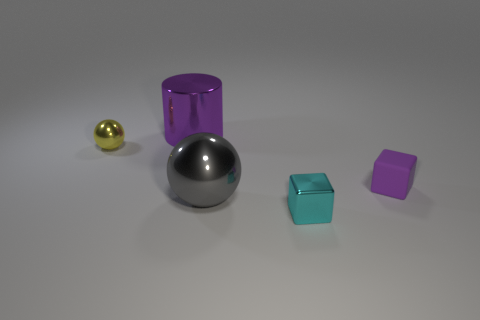What size is the metallic sphere to the left of the metallic cylinder?
Your answer should be compact. Small. How many other objects are there of the same color as the shiny block?
Your answer should be very brief. 0. There is a purple object that is on the right side of the object that is behind the small yellow metal object; what is it made of?
Your answer should be compact. Rubber. Does the tiny rubber thing that is to the right of the big purple metallic cylinder have the same color as the big metallic cylinder?
Keep it short and to the point. Yes. Are there any other things that are made of the same material as the tiny purple object?
Ensure brevity in your answer.  No. How many tiny purple things are the same shape as the small cyan thing?
Offer a very short reply. 1. What size is the gray ball that is made of the same material as the large cylinder?
Offer a terse response. Large. There is a sphere that is right of the tiny object to the left of the small shiny cube; is there a small cyan metal block right of it?
Provide a short and direct response. Yes. There is a metallic cylinder that is to the left of the matte thing; is it the same size as the small purple matte cube?
Keep it short and to the point. No. What number of purple objects are the same size as the yellow metal sphere?
Make the answer very short. 1. 